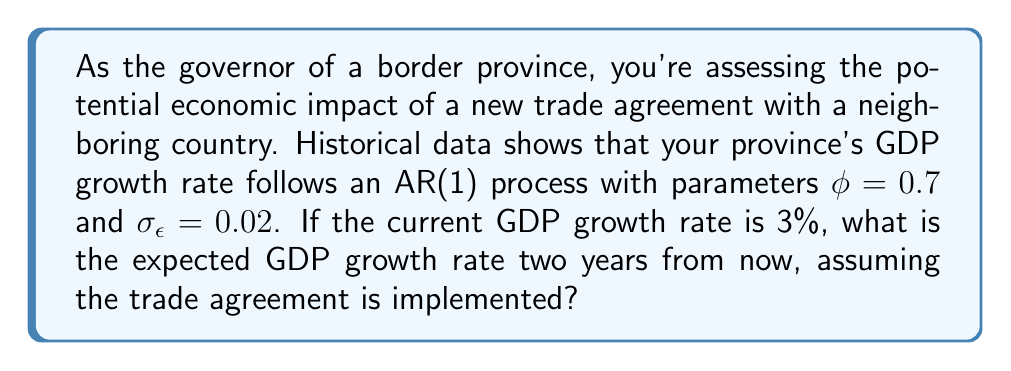Teach me how to tackle this problem. To solve this problem, we'll use the properties of an AR(1) process and time series analysis:

1) An AR(1) process is given by the equation:
   $$X_t = c + \phi X_{t-1} + \epsilon_t$$
   where $c$ is a constant, $\phi$ is the autoregressive parameter, and $\epsilon_t$ is white noise with variance $\sigma_{\epsilon}^2$.

2) In this case, we're not given $c$, but we can assume it's incorporated into the long-term mean. The long-term mean $\mu$ of an AR(1) process is:
   $$\mu = \frac{c}{1-\phi}$$

3) For forecasting an AR(1) process $h$ steps ahead, we use the formula:
   $$E[X_{t+h}|X_t] = \mu + \phi^h(X_t - \mu)$$

4) We don't know $\mu$, but we can estimate it using the current growth rate and the given $\phi$:
   $$0.03 = \mu + 0.7(0.03 - \mu)$$
   $$0.03 = \mu + 0.021 - 0.7\mu$$
   $$0.009 = 0.3\mu$$
   $$\mu = 0.03$$

5) Now we can forecast 2 years ahead ($h=2$):
   $$E[X_{t+2}|X_t] = 0.03 + 0.7^2(0.03 - 0.03)$$
   $$E[X_{t+2}|X_t] = 0.03 + 0 = 0.03$$

6) Convert to percentage: 0.03 * 100 = 3%
Answer: 3% 